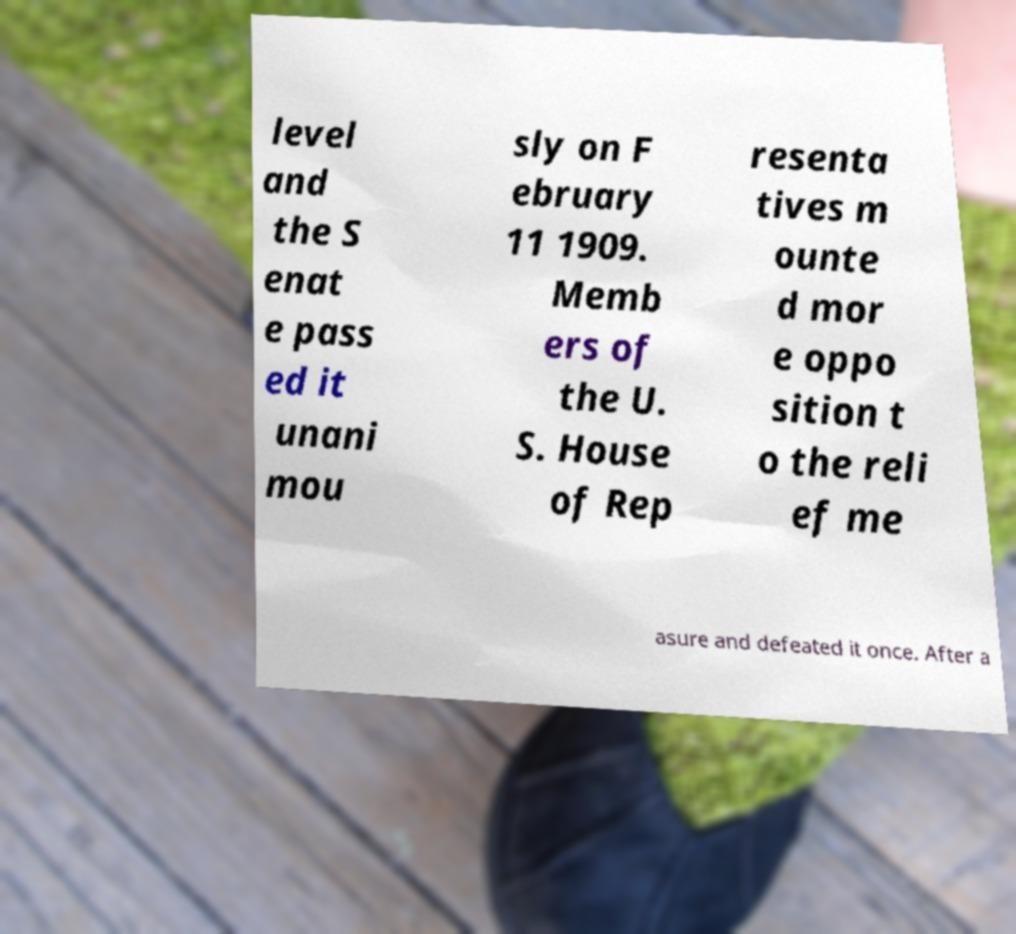Please read and relay the text visible in this image. What does it say? level and the S enat e pass ed it unani mou sly on F ebruary 11 1909. Memb ers of the U. S. House of Rep resenta tives m ounte d mor e oppo sition t o the reli ef me asure and defeated it once. After a 